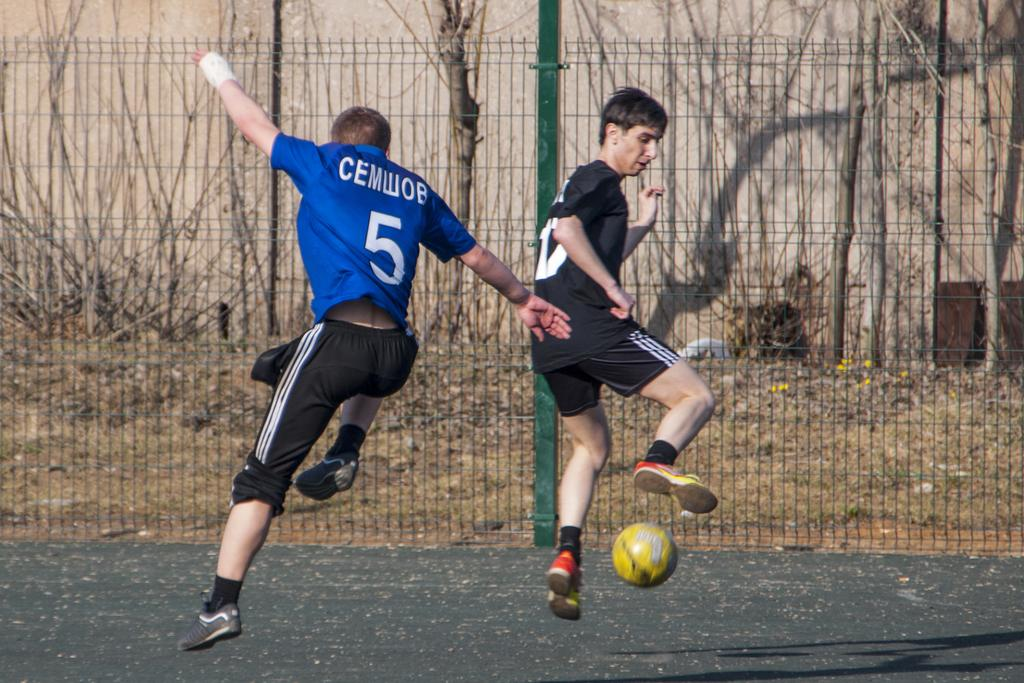<image>
Summarize the visual content of the image. Number 5 attempts to steal the ball away from the other player in black. 